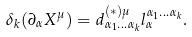Convert formula to latex. <formula><loc_0><loc_0><loc_500><loc_500>\delta _ { k } ( \partial _ { \alpha } X ^ { \mu } ) = d _ { \alpha _ { 1 } \dots \alpha _ { k } } ^ { ( \ast ) \mu } l _ { \alpha } ^ { \alpha _ { 1 } \dots \alpha _ { k } } .</formula> 